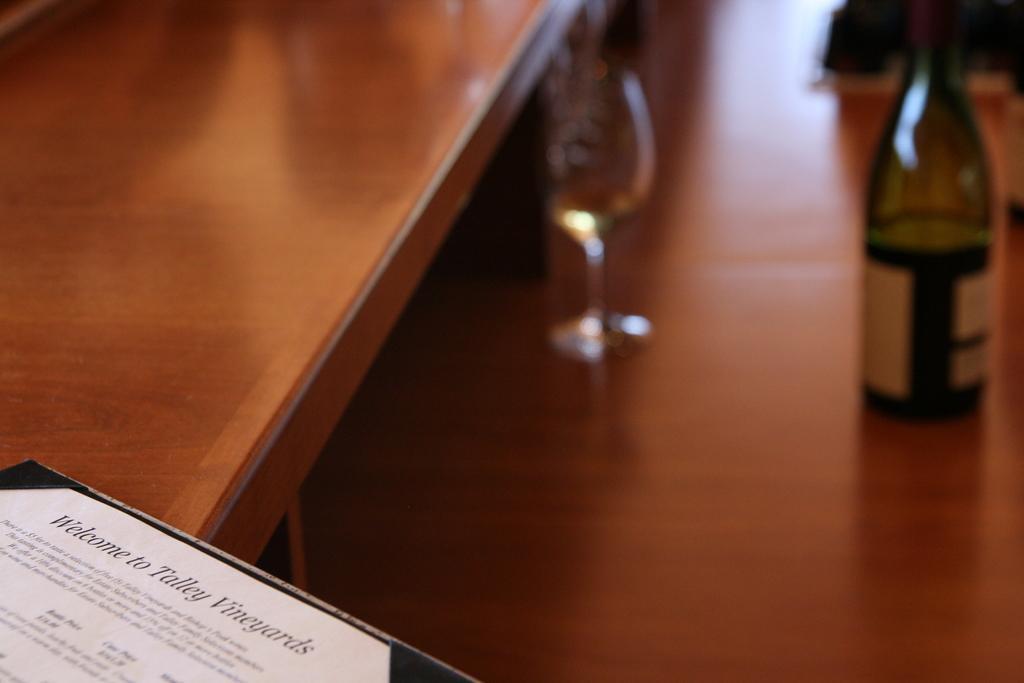How would you summarize this image in a sentence or two? This picture describe that on the beautiful wooden table we can see the green color beer bottle and a glass and a piece of paper in the front table on which welcome to tally vineyard is written. 